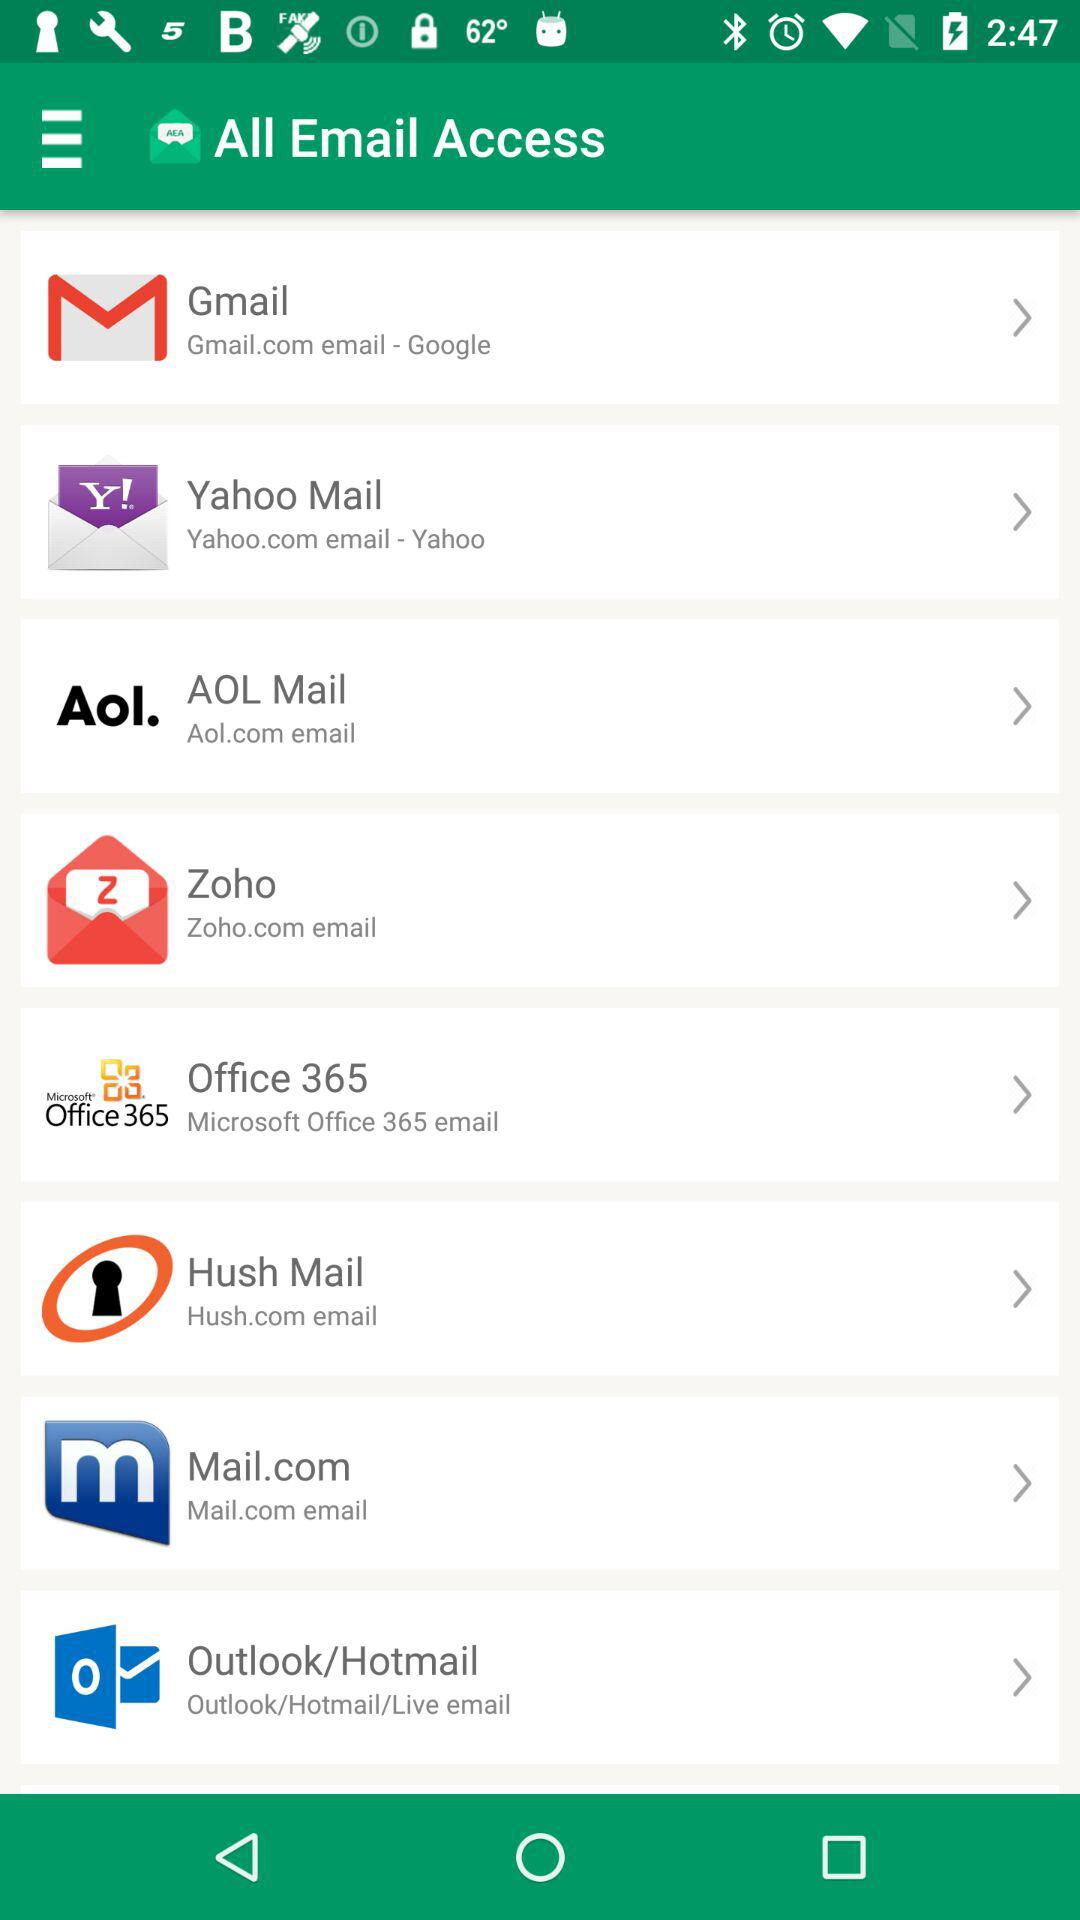How many email accounts are available to access?
Answer the question using a single word or phrase. 8 